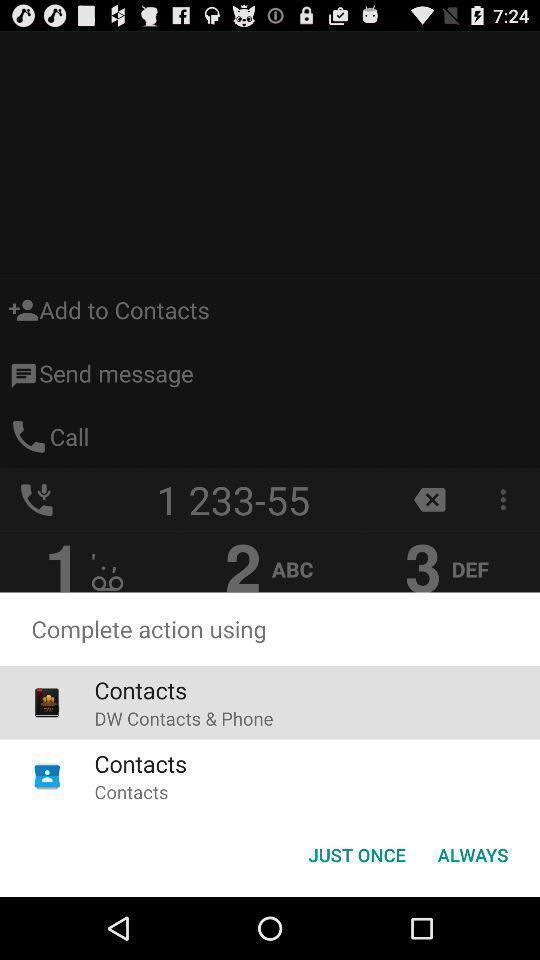Please provide a description for this image. Pop up displaying multiple options with icons. 